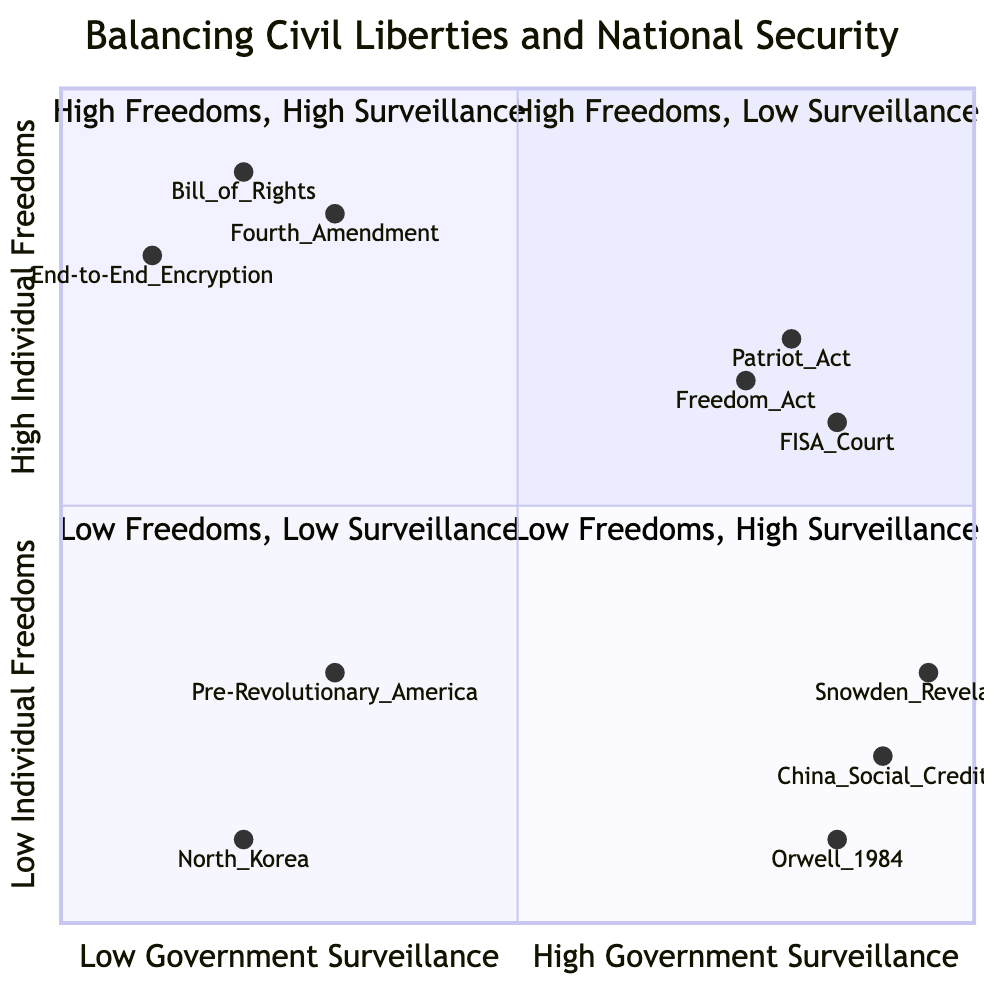What is the y-coordinate of the Bill of Rights in the diagram? The y-coordinate represents the level of individual freedoms for a specific node. For the Bill of Rights, its coordinates are [0.2, 0.9], so the y-coordinate is 0.9.
Answer: 0.9 Which quadrant contains the China’s Social Credit System? The China’s Social Credit System is located within the fourth quadrant, which corresponds to Low Individual Freedoms and High Government Surveillance.
Answer: Low Freedoms, High Surveillance How many examples are in the “High Individual Freedoms, Low Government Surveillance” quadrant? This quadrant has three examples listed: Bill of Rights, End-to-End Encryption, and Fourth Amendment. Thus, the total number is 3.
Answer: 3 What is the relationship between the Patriot Act and the Freedom Act in relation to individual freedoms? Both acts are situated in the second quadrant, which indicates they promote individual freedoms to some extent despite involving government surveillance, reflecting a relationship of increased surveillance but with considerations for civil liberties.
Answer: High Freedoms Which example has the highest government surveillance level? Among the examples listed, China’s Social Credit System has the highest government surveillance coding at a value of 0.9.
Answer: China’s Social Credit System What is the average y-coordinate of the examples in the "Low Individual Freedoms, Low Government Surveillance" quadrant? The y-coordinates for the examples North Korea and Pre-Revolutionary America are 0.1 and 0.3, respectively. The average is calculated as (0.1 + 0.3) / 2, which equals 0.2.
Answer: 0.2 Which example indicates the lowest level of government surveillance? North Korea, represented at a coordinate of [0.2, 0.1], has the lowest level of government surveillance, coded at 0.2.
Answer: North Korea In the “Low Individual Freedoms, High Government Surveillance” quadrant, which example has the lowest individual freedoms? The example with the lowest individual freedoms in this quadrant is Orwell’s 1984, coded with a y-coordinate of 0.1.
Answer: Orwell 1984 Which quadrant has the least amount of individual freedoms and surveillance combined? The third quadrant, “Low Individual Freedoms, Low Government Surveillance,” has the least amount of individual freedoms and surveillance based on its definitions.
Answer: Low Freedoms, Low Surveillance 